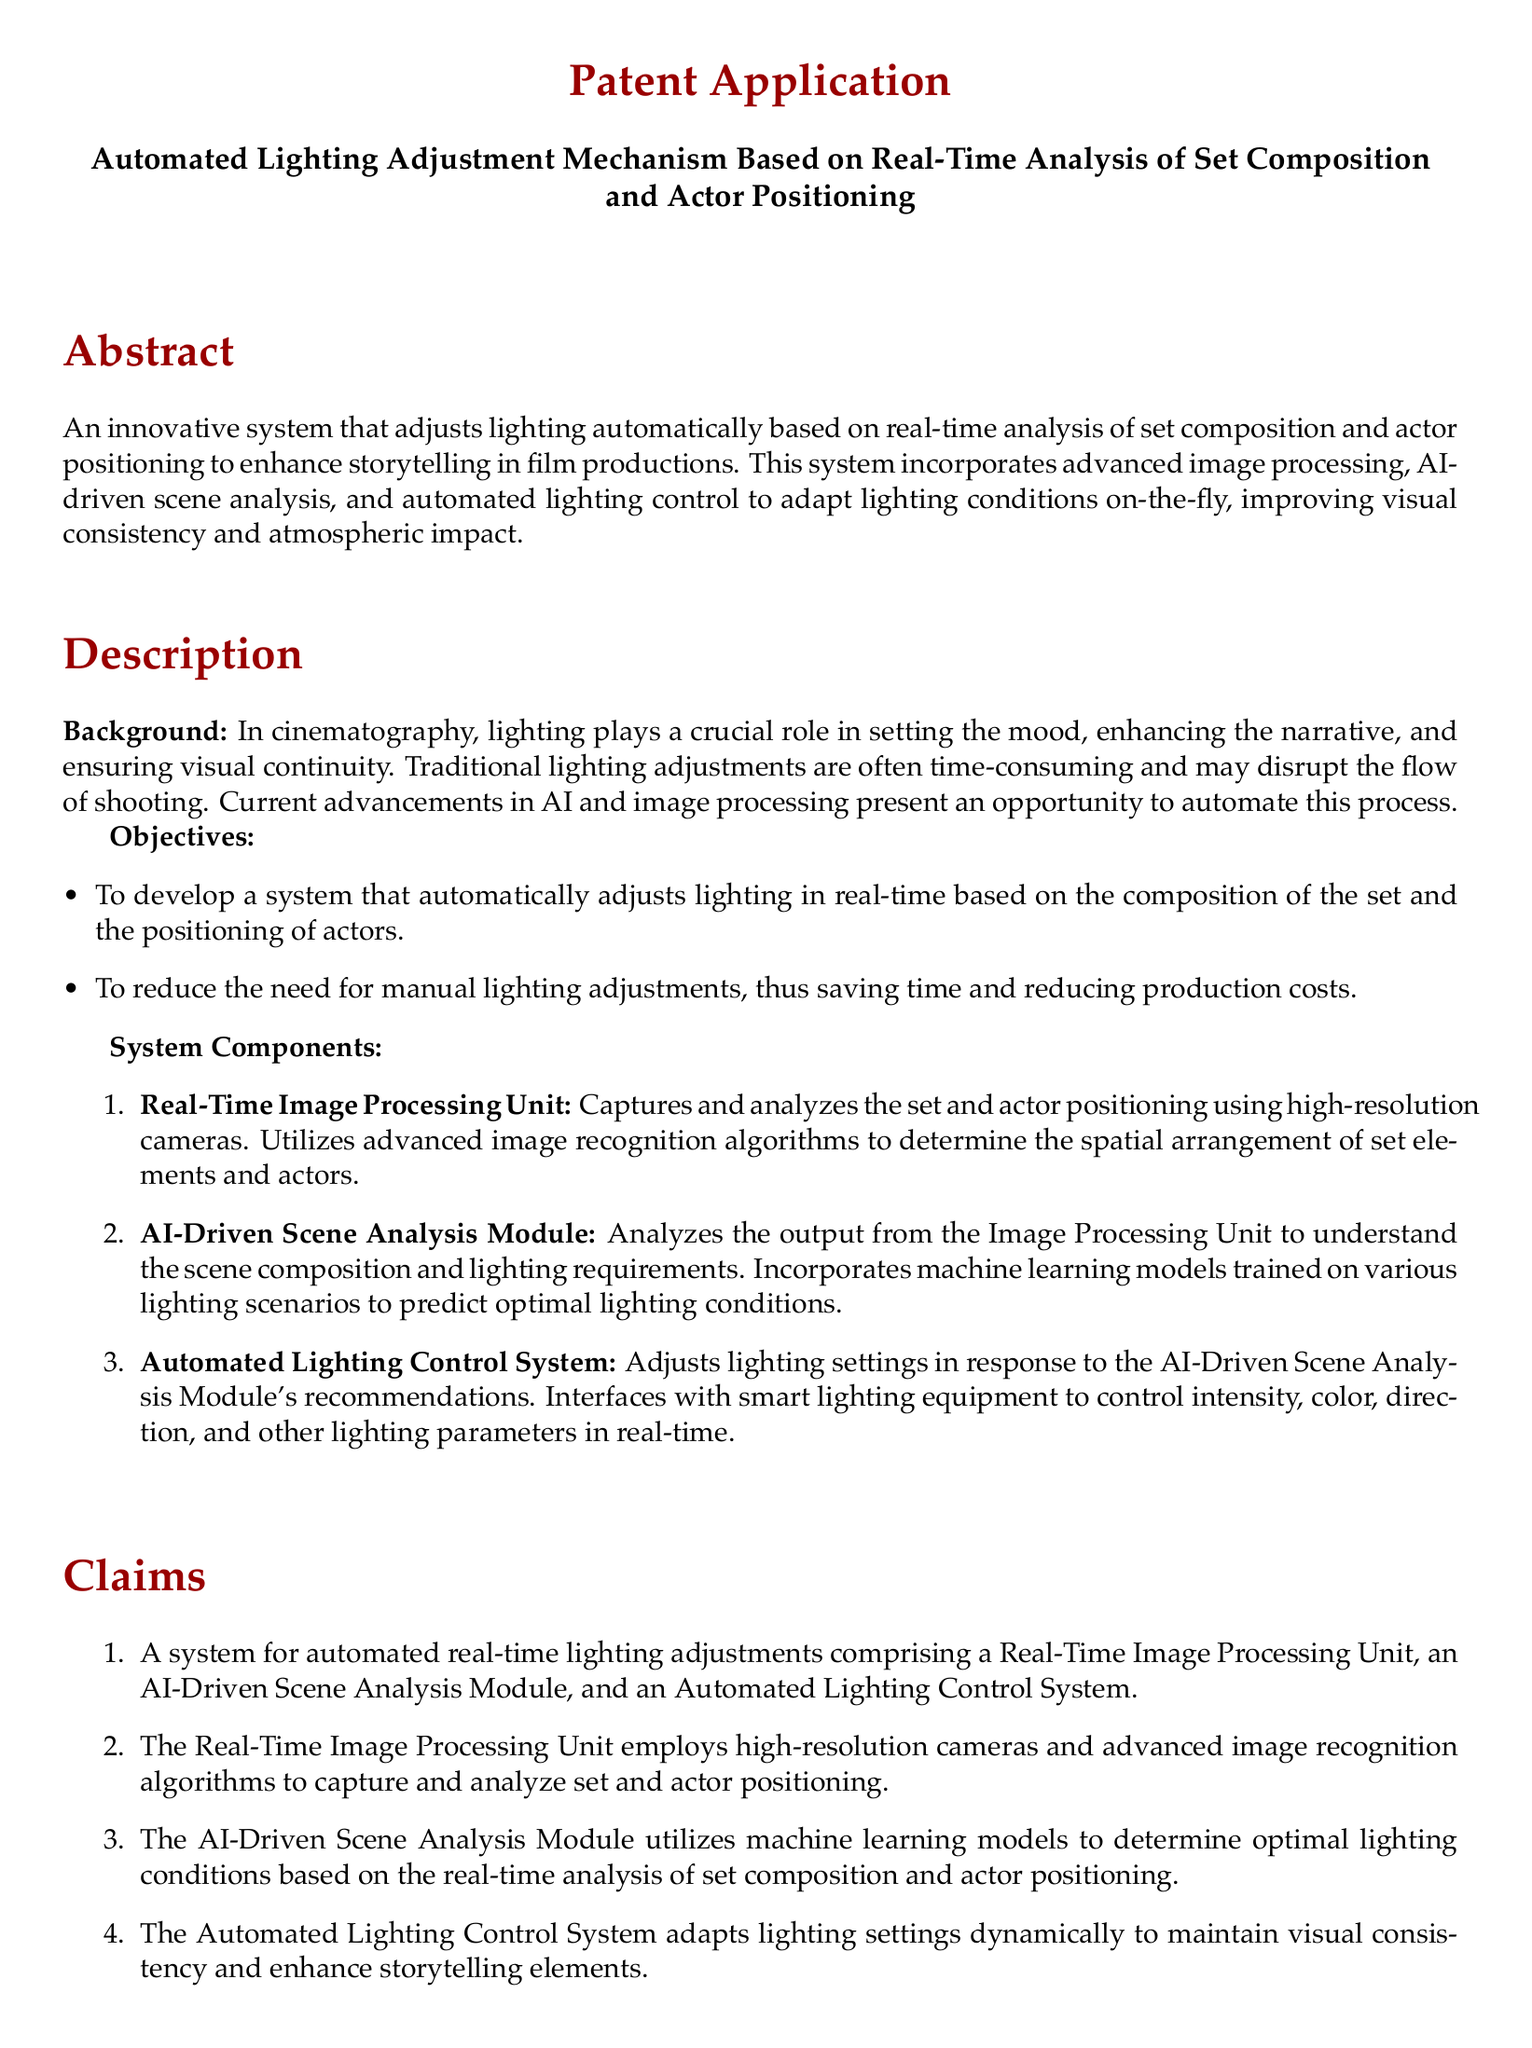What is the title of the patent application? The title is the main subject of the patent application and is provided at the beginning of the document.
Answer: Automated Lighting Adjustment Mechanism Based on Real-Time Analysis of Set Composition and Actor Positioning What are the two main objectives of the system? The objectives are listed under the "Objectives" section of the "Description" and briefly summarize the system's purpose.
Answer: To develop a system that automatically adjusts lighting in real-time based on the composition of the set and the positioning of actors; to reduce the need for manual lighting adjustments How many components are listed in the system description? The system components are presented as an enumerated list in the "System Components" section, specifying the key parts of the system.
Answer: Three What technology does the Real-Time Image Processing Unit use? This information can be found in the description of the Real-Time Image Processing Unit's functionalities within the "System Components" section.
Answer: High-resolution cameras Which module analyzes the output from the Image Processing Unit? The module that analyzes the output is mentioned in relation to its function in understanding the scene composition and lighting requirements.
Answer: AI-Driven Scene Analysis Module What year was the first reference published? The publication year is associated with the first reference listed in the "References" section and provides insight into the timeline of relevant research.
Answer: 2021 What is the role of the Automated Lighting Control System? The role is described in the context of how it interacts with the AI-Driven Scene Analysis Module, highlighting its purpose in real-time operations.
Answer: Adjusts lighting settings How many claims are made in the document? The number of claims can be found in the "Claims" section, which enumerates the specific assertions regarding the system's functionality.
Answer: Four 